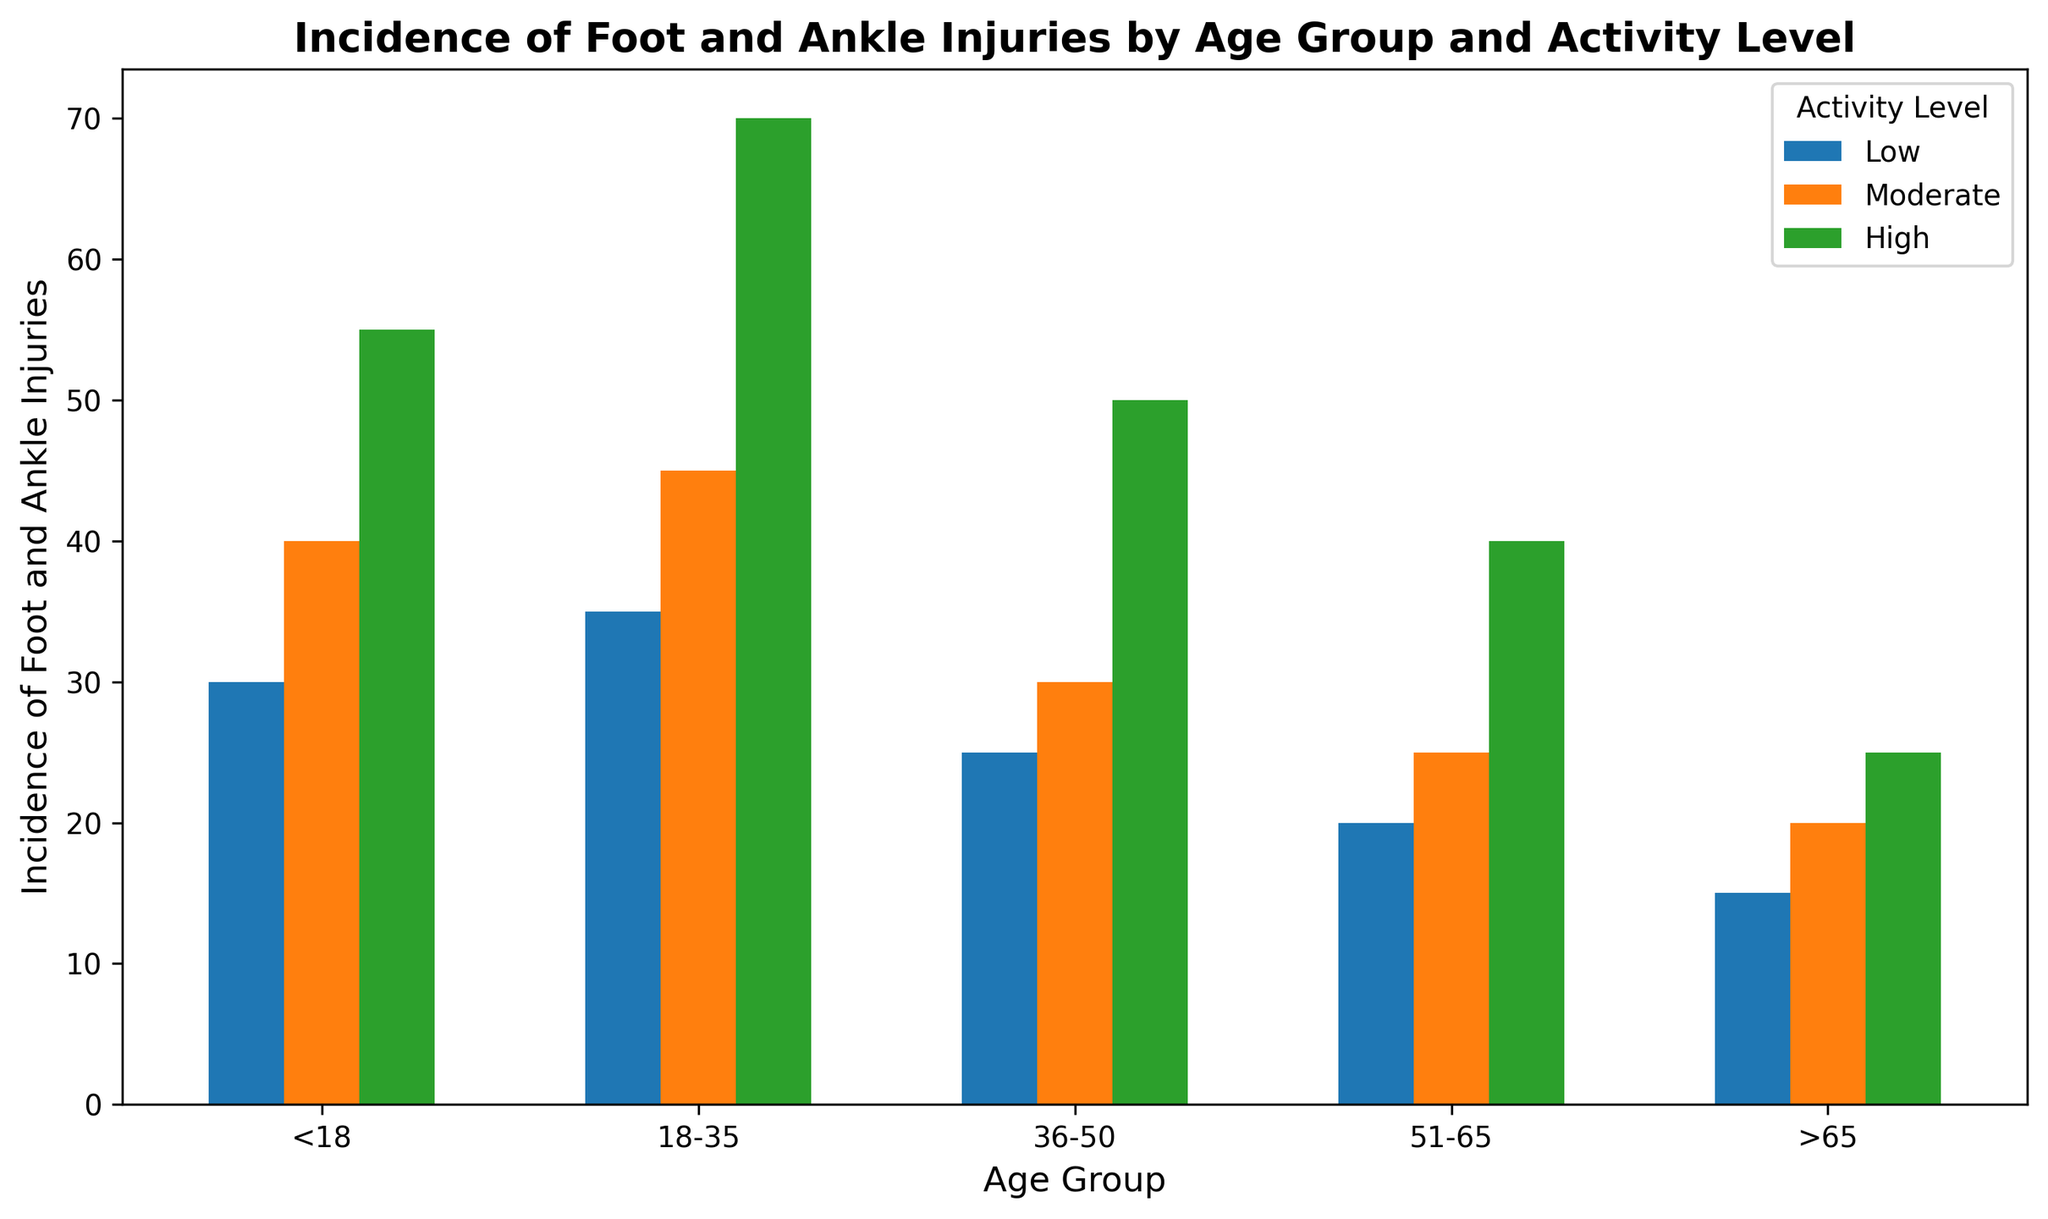What age group has the highest incidence of injuries in high activity level? Look at the bar heights for the high activity level across different age groups. The highest bar corresponds to the 18-35 age group.
Answer: 18-35 What is the sum of incidences for the age group 51-65 across all activity levels? Add the incidences for low (20), moderate (25), and high (40) activity levels in the 51-65 age group: 20 + 25 + 40 = 85.
Answer: 85 Which activity level has the highest overall incidence in the <18 age group? Compare the bar heights for low (30), moderate (40), and high (55) activity levels in the <18 age group. The highest bar corresponds to the high activity level.
Answer: High Is the incidence of moderate activity level in the 18-35 age group greater than the high activity level in the >65 age group? Compare the bars for moderate activity level in 18-35 (45) and high activity level in >65 (25). The moderate activity level in 18-35 is higher.
Answer: Yes What is the average incidence of injuries for the low activity level across all age groups? Sum the incidences for low activity level across all age groups (30 + 35 + 25 + 20 + 15 = 125) and divide by the number of age groups (5): 125 / 5 = 25.
Answer: 25 Which age group has the lowest incidence of injuries in the moderate activity level? Compare the bar heights for the moderate activity level across all age groups. The lowest bar corresponds to the >65 age group (20).
Answer: >65 How much more is the incidence of injuries in high activity level than low activity level for the 36-50 age group? Subtract the incidence of low activity level (25) from high activity level (50) for the 36-50 age group: 50 - 25 = 25.
Answer: 25 Which age group has the most similar incidence of injuries between moderate and high activity levels? Compare the differences between moderate and high activity level incidences for each age group. The smallest difference is in the >65 age group (20 - 25 = 5).
Answer: >65 What is the total incidence of injuries for the high activity level across all age groups? Sum the incidences for high activity level across all age groups (55 + 70 + 50 + 40 + 25 = 240).
Answer: 240 Which activity level consistently shows a decreasing trend in incidence as age increases? Observe the bars for each activity level across increasing age groups. The low activity level has a consistent decrease in incidence (30, 35, 25, 20, 15).
Answer: Low 